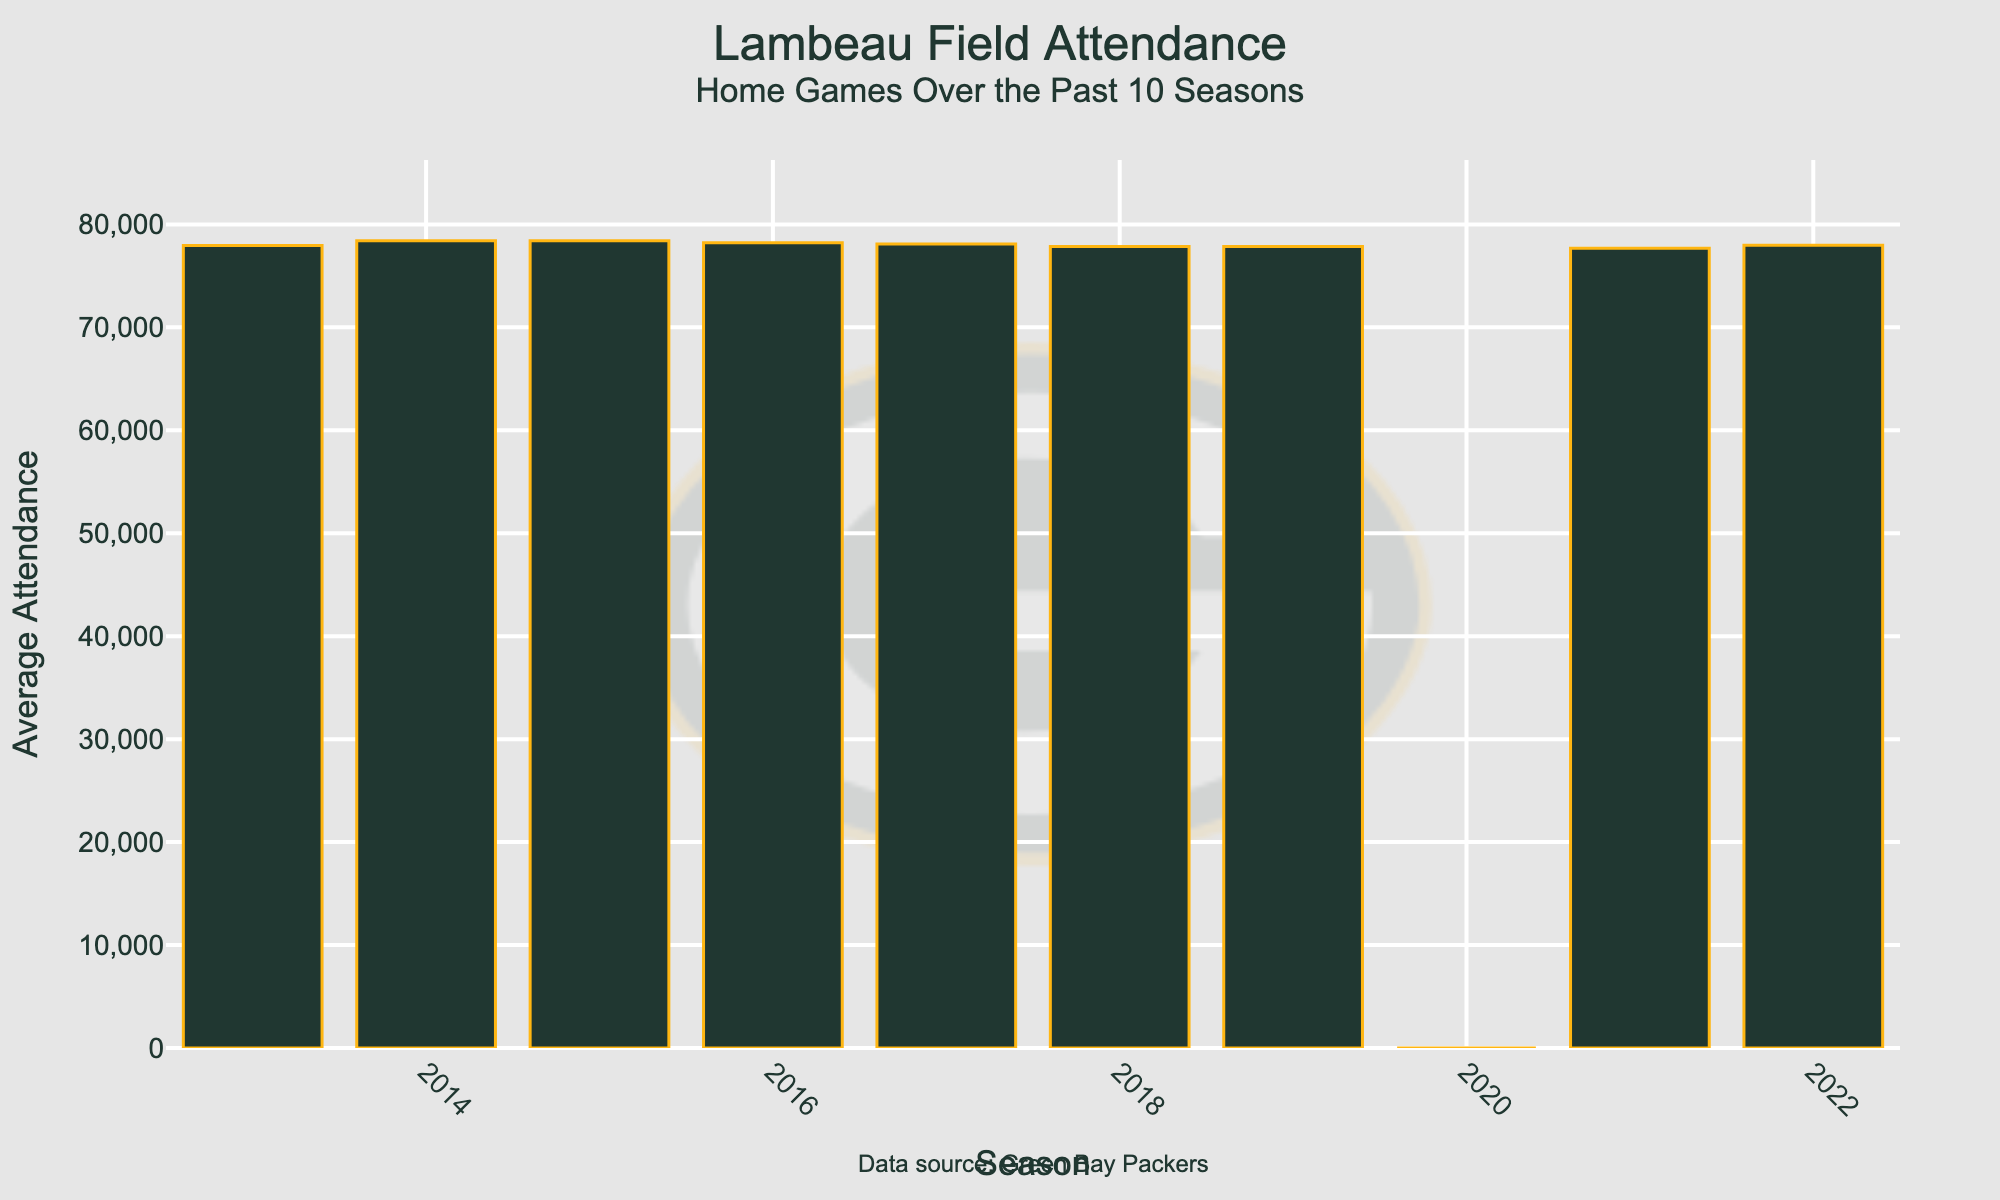What was the average attendance in the 2020 season? The data shows attendance for each season as a bar. The bar for 2020 is significantly lower than the others and is labeled with 0 attendance.
Answer: 0 Which season had the highest average attendance? By examining the height of the bars, the 2015 season has the tallest bar. Hence, 2015 had the highest average attendance.
Answer: 2015 Calculate the difference in average attendance between 2014 and 2013. The bar for 2014 shows an average attendance of 78,413, while for 2013, it's 77,947. The difference is calculated as 78,413 - 77,947.
Answer: 466 How many seasons had an average attendance above 78,000? By counting the bars that exceed the 78,000 mark, we find that the seasons 2015, 2016, and 2017 surpassed this value.
Answer: 3 What is the trend in average attendance from 2017 to 2019? From 2017 to 2019, the average attendance decreases. 2017 had 78,092, 2018 had 77,845, and 2019 also had 77,845. This indicates a slight decline or stabilization over these years.
Answer: Decreasing Compare the average attendance for seasons 2018 and 2022. Which is greater? The bars for both 2018 and 2022 show average attendance, with 2018 being 77,845 and 2022 being 77,979. Therefore, 2022 is greater.
Answer: 2022 Calculate the average attendance over the 10 seasons excluding 2020. Sum the average attendance for each season excluding 2020: (77,979 + 77,690 + 0 + 77,845 + 77,845 + 78,092 + 78,215 + 78,414 + 78,413 + 77,947) / 9. The sum is 701,440 and the average is 701,440 / 9.
Answer: 77,938.89 What is the impact of the 2020 season on the overall average attendance over the 10 seasons? Without 2020, the average is 77,938.89. Including 2020, we sum the total attendance over 10 years (701,440) and divide by 10 seasons: 701,440 / 10 = 70,144. The lower average shows the significant impact of the 2020 season's 0 attendance.
Answer: Decrease 